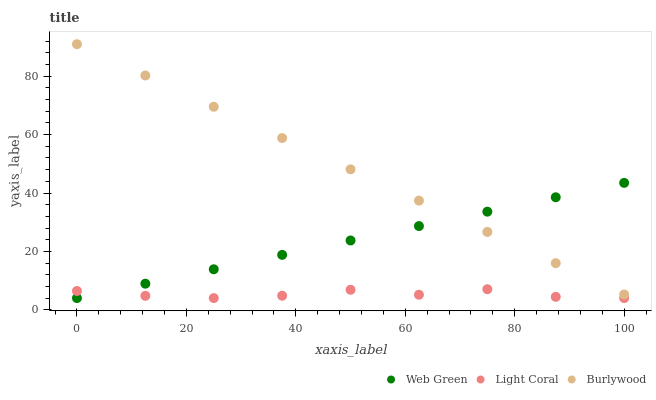Does Light Coral have the minimum area under the curve?
Answer yes or no. Yes. Does Burlywood have the maximum area under the curve?
Answer yes or no. Yes. Does Web Green have the minimum area under the curve?
Answer yes or no. No. Does Web Green have the maximum area under the curve?
Answer yes or no. No. Is Web Green the smoothest?
Answer yes or no. Yes. Is Light Coral the roughest?
Answer yes or no. Yes. Is Burlywood the smoothest?
Answer yes or no. No. Is Burlywood the roughest?
Answer yes or no. No. Does Light Coral have the lowest value?
Answer yes or no. Yes. Does Burlywood have the lowest value?
Answer yes or no. No. Does Burlywood have the highest value?
Answer yes or no. Yes. Does Web Green have the highest value?
Answer yes or no. No. Is Light Coral less than Burlywood?
Answer yes or no. Yes. Is Burlywood greater than Light Coral?
Answer yes or no. Yes. Does Light Coral intersect Web Green?
Answer yes or no. Yes. Is Light Coral less than Web Green?
Answer yes or no. No. Is Light Coral greater than Web Green?
Answer yes or no. No. Does Light Coral intersect Burlywood?
Answer yes or no. No. 